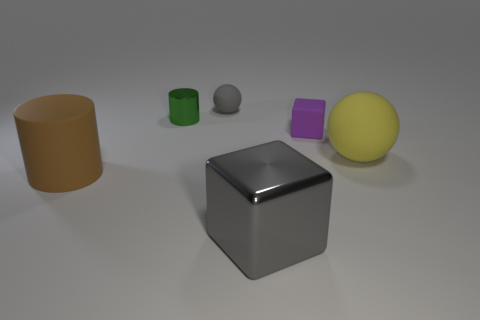What number of balls are shiny objects or large gray metallic things?
Your answer should be compact. 0. There is a cylinder that is in front of the matte sphere that is on the right side of the big thing in front of the brown object; what is it made of?
Keep it short and to the point. Rubber. What is the size of the object that is the same color as the tiny matte sphere?
Ensure brevity in your answer.  Large. Is the number of things behind the big gray object greater than the number of large gray metal cubes?
Provide a short and direct response. Yes. Are there any objects that have the same color as the metal cube?
Your answer should be very brief. Yes. There is a cube that is the same size as the yellow object; what color is it?
Provide a short and direct response. Gray. What number of gray things are left of the green metal cylinder that is behind the small block?
Your answer should be compact. 0. What number of things are either cylinders that are in front of the purple matte thing or brown cubes?
Provide a succinct answer. 1. What number of large blocks have the same material as the large sphere?
Keep it short and to the point. 0. There is a small rubber thing that is the same color as the shiny cube; what shape is it?
Keep it short and to the point. Sphere. 